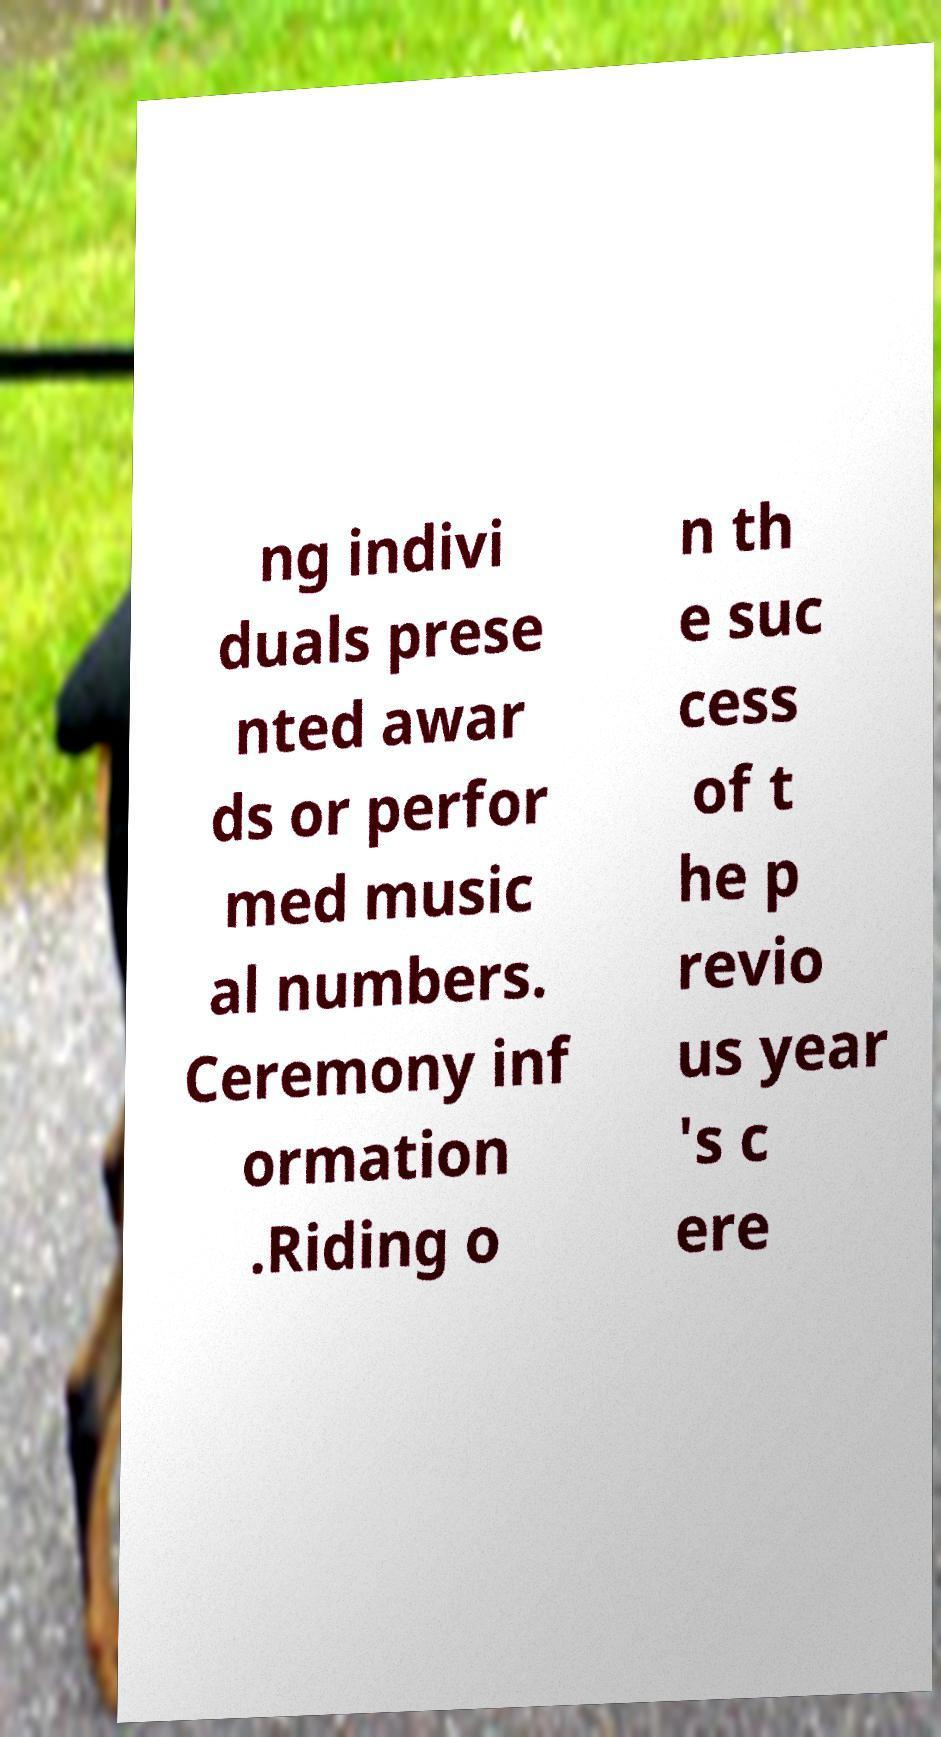There's text embedded in this image that I need extracted. Can you transcribe it verbatim? ng indivi duals prese nted awar ds or perfor med music al numbers. Ceremony inf ormation .Riding o n th e suc cess of t he p revio us year 's c ere 